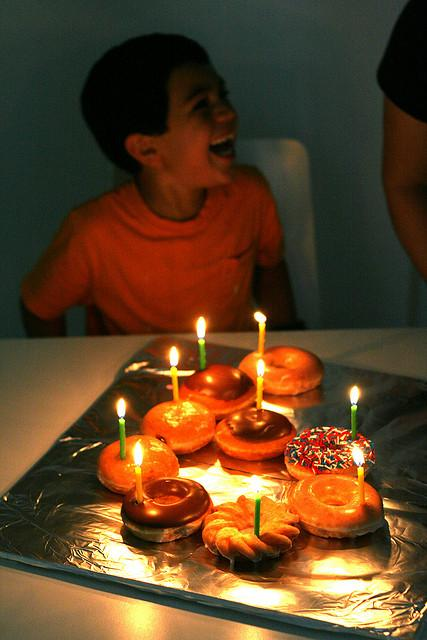What color is the only icing element used for the birthday donuts? Please explain your reasoning. brown. The donuts are colored brown. 